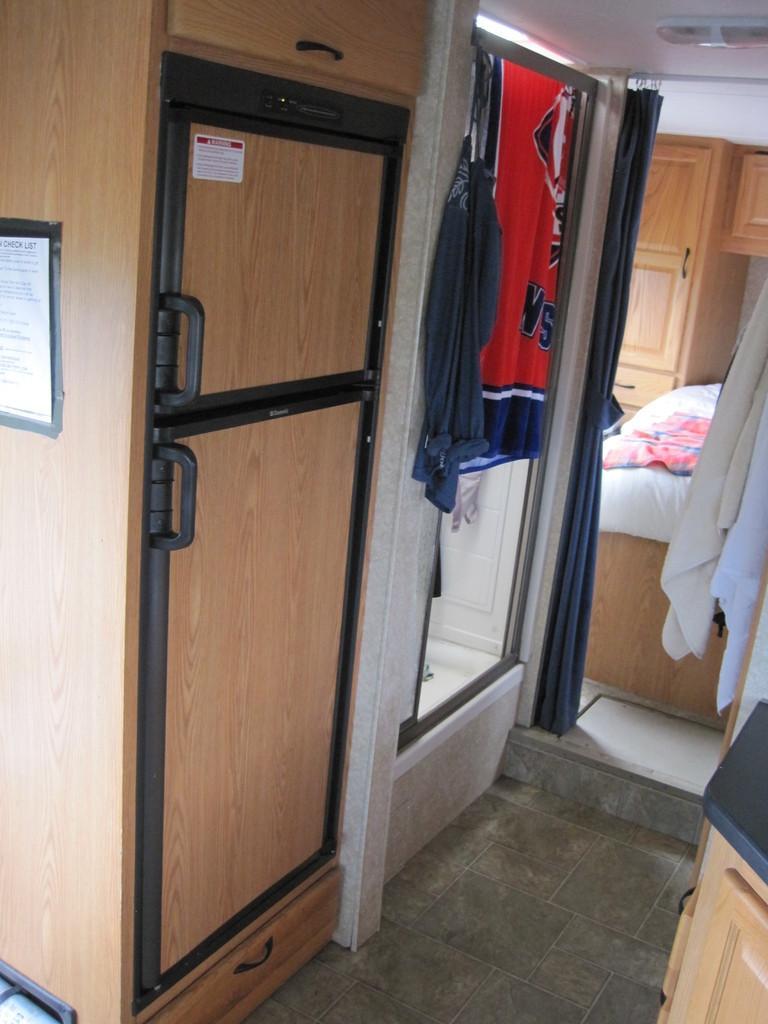In one or two sentences, can you explain what this image depicts? In this picture we can see the text on the objects. We can see clothes, wooden objects and other objects. 